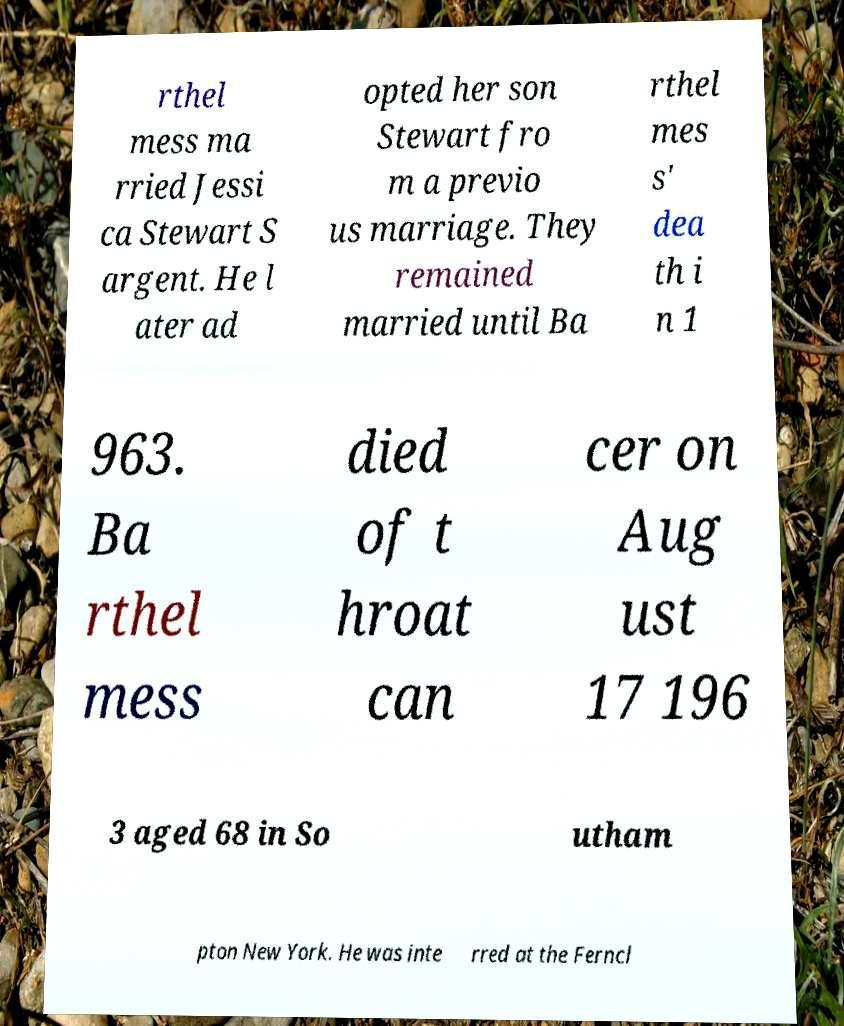Could you extract and type out the text from this image? rthel mess ma rried Jessi ca Stewart S argent. He l ater ad opted her son Stewart fro m a previo us marriage. They remained married until Ba rthel mes s' dea th i n 1 963. Ba rthel mess died of t hroat can cer on Aug ust 17 196 3 aged 68 in So utham pton New York. He was inte rred at the Ferncl 